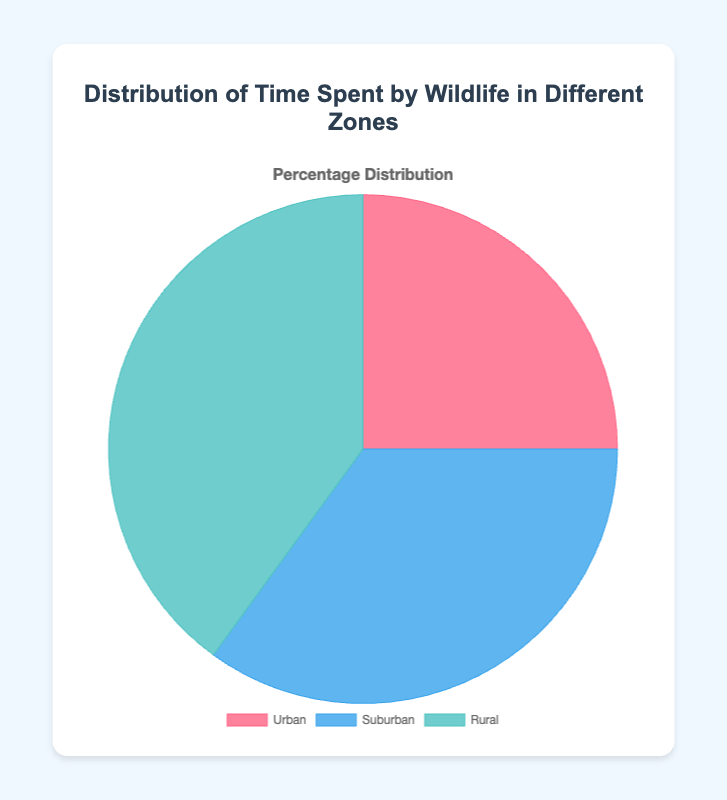What is the percentage of time wildlife spends in suburban areas? The figure shows a pie chart with the label "Suburban" and a corresponding percentage of 35%.
Answer: 35% Which zone has the highest percentage of time spent by wildlife? By comparing the percentages of all zones in the figure: Urban (25%), Suburban (35%), and Rural (40%), it is clear that the Rural zone has the highest percentage.
Answer: Rural What is the combined percentage of time wildlife spends in urban and suburban areas? Add the percentages of Urban (25%) and Suburban (35%). 25% + 35% = 60%.
Answer: 60% How much greater is the percentage of time spent by wildlife in rural areas compared to urban areas? Subtract the Urban percentage (25%) from the Rural percentage (40%). 40% - 25% = 15%.
Answer: 15% Are the time percentages spent by wildlife more balanced between suburban and rural zones or between urban and suburban zones? Observe the differences between the zones: Urban and Suburban (35% - 25% = 10%) versus Suburban and Rural (40% - 35% = 5%). Since 5% is less than 10%, the time percentages are more balanced between suburban and rural zones.
Answer: Suburban and Rural zones By what factor is the time spent by wildlife in rural areas greater than in urban areas? Divide the Rural percentage (40%) by the Urban percentage (25%). 40% / 25% = 1.6.
Answer: 1.6 Which zone is represented by the blue color on the pie chart? Looking at the color representation in the figure, the Suburban zone is denoted by the blue color.
Answer: Suburban What is the average percentage of time spent by wildlife across all zones? Add all the percentages (25% + 35% + 40% = 100%) and then divide by the number of zones (3). 100% / 3 ≈ 33.33%.
Answer: 33.33% If the pie chart data were to be displayed as a bar chart, which bar would be the tallest? The zone with the highest percentage would correspond to the tallest bar in a bar chart. Since Rural has the highest percentage (40%), its bar would be the tallest.
Answer: Rural What percentage difference would you report if the time spent by wildlife in suburban areas increased by 10%? Increase the Suburban percentage by 10% (35% + 10% = 45%) and then calculate the change compared to the current total percentage (100% + 10% = 110%). The difference is 10%.
Answer: 10% 